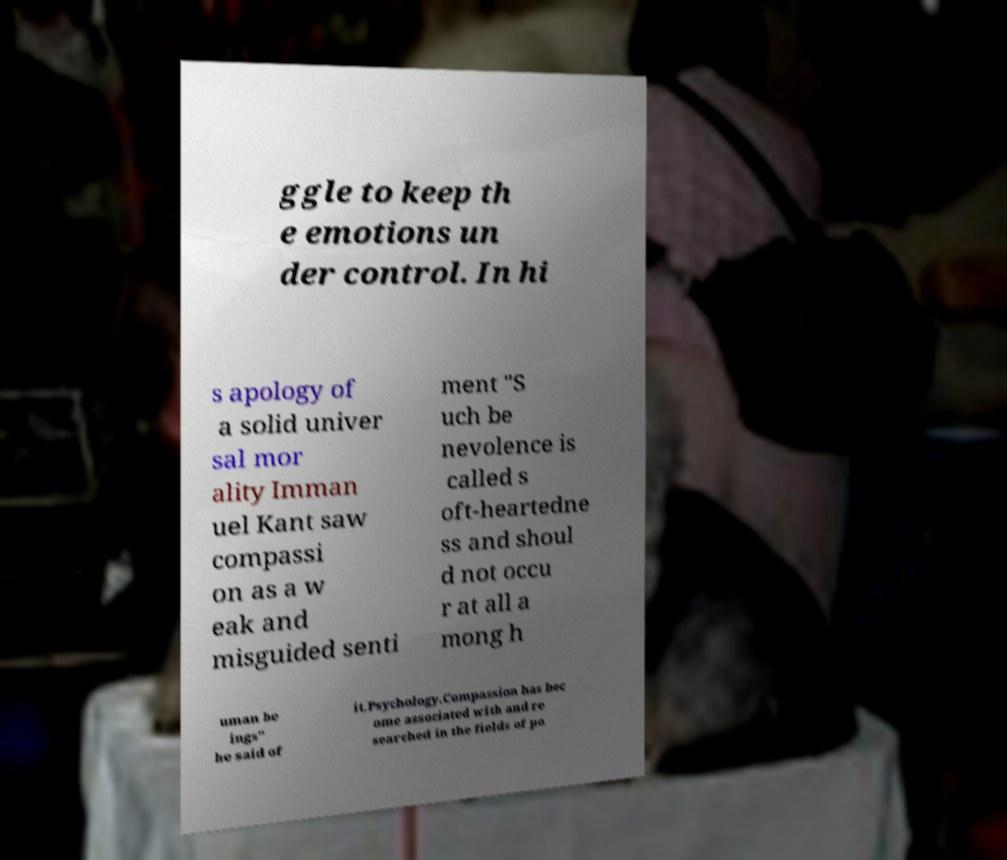I need the written content from this picture converted into text. Can you do that? ggle to keep th e emotions un der control. In hi s apology of a solid univer sal mor ality Imman uel Kant saw compassi on as a w eak and misguided senti ment "S uch be nevolence is called s oft-heartedne ss and shoul d not occu r at all a mong h uman be ings" he said of it.Psychology.Compassion has bec ome associated with and re searched in the fields of po 